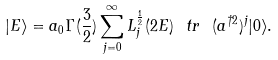<formula> <loc_0><loc_0><loc_500><loc_500>| E \rangle = a _ { 0 } \Gamma ( \frac { 3 } { 2 } ) \sum _ { j = 0 } ^ { \infty } L ^ { \frac { 1 } { 2 } } _ { j } ( 2 E ) \ t r \ ( a ^ { \dagger 2 } ) ^ { j } | 0 \rangle .</formula> 